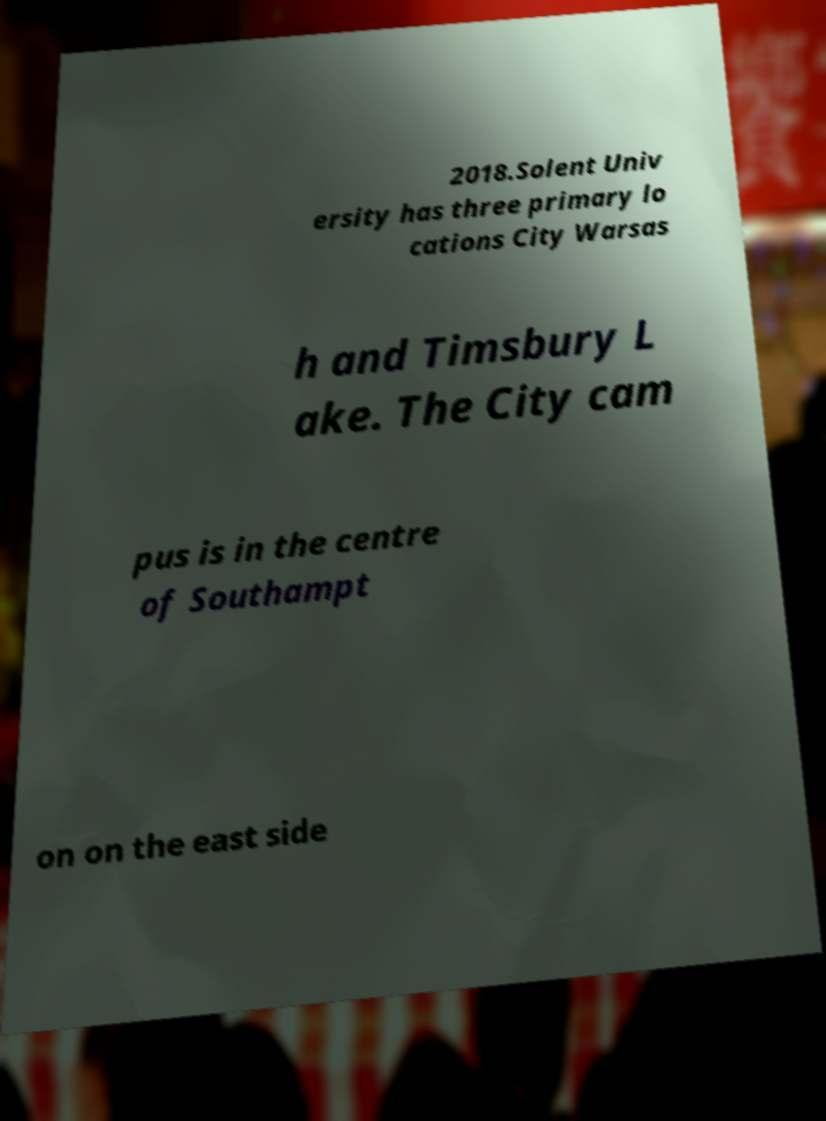There's text embedded in this image that I need extracted. Can you transcribe it verbatim? 2018.Solent Univ ersity has three primary lo cations City Warsas h and Timsbury L ake. The City cam pus is in the centre of Southampt on on the east side 